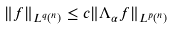Convert formula to latex. <formula><loc_0><loc_0><loc_500><loc_500>\| f \| _ { L ^ { q } ( \real ^ { n } ) } \leq c \| \Lambda _ { \alpha } f \| _ { L ^ { p } ( \real ^ { n } ) }</formula> 